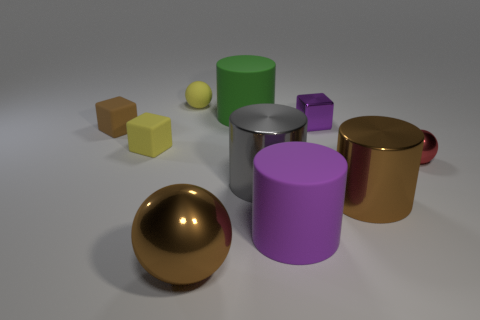Do the small object on the right side of the brown cylinder and the small purple block have the same material?
Your answer should be very brief. Yes. What is the large purple thing made of?
Provide a short and direct response. Rubber. What is the size of the matte thing in front of the small yellow matte cube?
Offer a very short reply. Large. Is there anything else that is the same color as the large sphere?
Give a very brief answer. Yes. There is a purple thing that is behind the yellow object that is to the left of the yellow sphere; is there a large gray cylinder behind it?
Keep it short and to the point. No. Do the metallic ball that is in front of the tiny red metallic thing and the rubber sphere have the same color?
Give a very brief answer. No. What number of balls are either red metallic things or brown shiny objects?
Provide a short and direct response. 2. There is a tiny object that is to the right of the purple object behind the large purple rubber object; what shape is it?
Give a very brief answer. Sphere. What is the size of the purple cylinder behind the shiny sphere that is in front of the sphere that is to the right of the purple matte cylinder?
Your answer should be compact. Large. Does the red sphere have the same size as the gray metallic object?
Keep it short and to the point. No. 